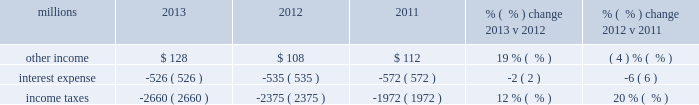Supplies .
Expenses for purchased services increased 10% ( 10 % ) compared to 2012 due to logistics management fees , an increase in locomotive overhauls and repairs on jointly owned property .
Expenses for contract services increased $ 103 million in 2012 versus 2011 , primarily due to increased demand for transportation services purchased by our logistics subsidiaries for their customers and additional costs for repair and maintenance of locomotives and freight cars .
Depreciation 2013 the majority of depreciation relates to road property , including rail , ties , ballast , and other track material .
Depreciation was up 1% ( 1 % ) compared to 2012 .
Recent depreciation studies allowed us to use longer estimated service lives for certain equipment , which partially offset the impact of a higher depreciable asset base resulting from larger capital spending in recent years .
A higher depreciable asset base , reflecting ongoing capital spending , increased depreciation expense in 2012 compared to 2011 .
Equipment and other rents 2013 equipment and other rents expense primarily includes rental expense that the railroad pays for freight cars owned by other railroads or private companies ; freight car , intermodal , and locomotive leases ; and office and other rent expenses .
Additional container costs resulting from the logistics management arrangement , and increased automotive shipments , partially offset by lower cycle times drove a $ 51 million increase in our short-term freight car rental expense versus 2012 .
Conversely , lower locomotive and freight car lease expenses partially offset the higher freight car rental expense .
Increased automotive and intermodal shipments , partially offset by improved car-cycle times , drove an increase in our short-term freight car rental expense in 2012 compared to 2011 .
Conversely , lower locomotive lease expense partially offset the higher freight car rental expense .
Other 2013 other expenses include state and local taxes , freight , equipment and property damage , utilities , insurance , personal injury , environmental , employee travel , telephone and cellular , computer software , bad debt , and other general expenses .
Higher property taxes and costs associated with damaged freight and property increased other costs in 2013 compared to 2012 .
Continued improvement in our safety performance and lower estimated liability for personal injury , which reduced our personal injury expense year-over-year , partially offset increases in other costs .
Other costs in 2012 were slightly higher than 2011 primarily due to higher property taxes .
Despite continual improvement in our safety experience and lower estimated annual costs , personal injury expense increased in 2012 compared to 2011 , as the liability reduction resulting from historical claim experience was less than the reduction in 2011 .
Non-operating items millions 2013 2012 2011 % (  % ) change 2013 v 2012 % (  % ) change 2012 v 2011 .
Other income 2013 other income increased in 2013 versus 2012 due to higher gains from real estate sales and increased lease income , including the favorable impact from the $ 17 million settlement of a land lease contract .
These increases were partially offset by interest received from a tax refund in 2012 .
Other income decreased in 2012 versus 2011 due to lower gains from real estate sales and higher environmental costs associated with non-operating properties , partially offset by interest received from a tax refund .
Interest expense 2013 interest expense decreased in 2013 versus 2012 due to a lower effective interest rate of 5.7% ( 5.7 % ) in 2013 versus 6.0% ( 6.0 % ) in 2012 .
The increase in the weighted-average debt level to $ 9.6 billion in 2013 from $ 9.1 billion in 2012 partially offset the impact of the lower effective interest rate .
Interest expense decreased in 2012 versus 2011 reflecting a lower effective interest rate in 2012 of 6.0% ( 6.0 % ) versus 6.2% ( 6.2 % ) in 2011 as the debt level did not materially change from 2011 to 2012. .
What was the average other income from 2011 to 2013? 
Computations: ((112 + (128 + 108)) / 3)
Answer: 116.0. 